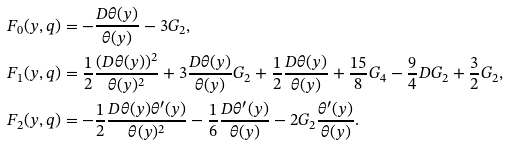<formula> <loc_0><loc_0><loc_500><loc_500>F _ { 0 } ( y , q ) & = - \frac { D \theta ( y ) } { \theta ( y ) } - 3 G _ { 2 } , \\ F _ { 1 } ( y , q ) & = \frac { 1 } { 2 } \frac { ( D \theta ( y ) ) ^ { 2 } } { \theta ( y ) ^ { 2 } } + 3 \frac { D \theta ( y ) } { \theta ( y ) } G _ { 2 } + \frac { 1 } { 2 } \frac { D \theta ( y ) } { \theta ( y ) } + \frac { 1 5 } { 8 } G _ { 4 } - \frac { 9 } { 4 } D G _ { 2 } + \frac { 3 } { 2 } G _ { 2 } , \\ F _ { 2 } ( y , q ) & = - \frac { 1 } { 2 } \frac { D \theta ( y ) \theta ^ { \prime } ( y ) } { \theta ( y ) ^ { 2 } } - \frac { 1 } { 6 } \frac { D \theta ^ { \prime } ( y ) } { \theta ( y ) } - 2 G _ { 2 } \frac { \theta ^ { \prime } ( y ) } { \theta ( y ) } . \\</formula> 